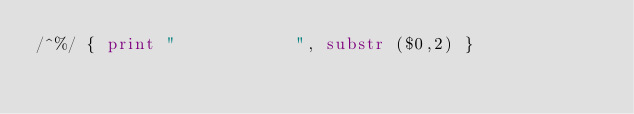<code> <loc_0><loc_0><loc_500><loc_500><_Awk_>/^%/ { print "            ", substr ($0,2) }
</code> 